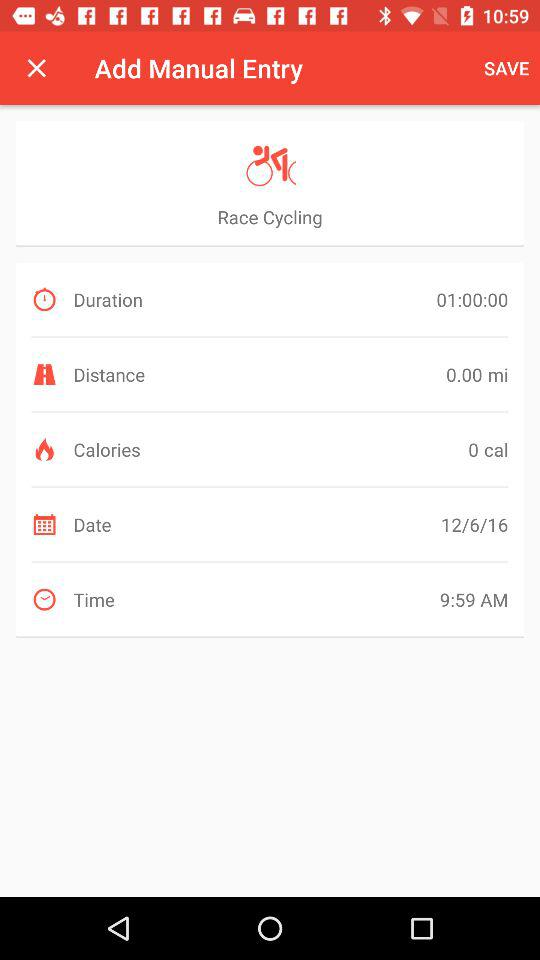What is the duration of the race? The duration is 1 hour. 